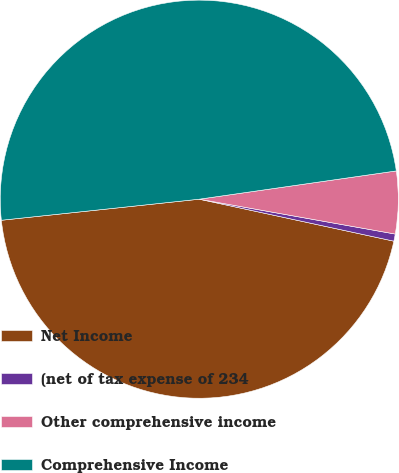Convert chart to OTSL. <chart><loc_0><loc_0><loc_500><loc_500><pie_chart><fcel>Net Income<fcel>(net of tax expense of 234<fcel>Other comprehensive income<fcel>Comprehensive Income<nl><fcel>44.93%<fcel>0.58%<fcel>5.07%<fcel>49.42%<nl></chart> 